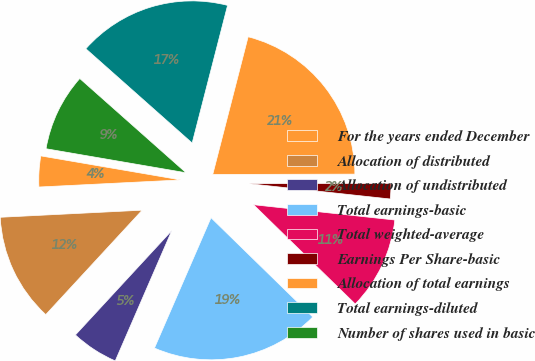Convert chart. <chart><loc_0><loc_0><loc_500><loc_500><pie_chart><fcel>For the years ended December<fcel>Allocation of distributed<fcel>Allocation of undistributed<fcel>Total earnings-basic<fcel>Total weighted-average<fcel>Earnings Per Share-basic<fcel>Allocation of total earnings<fcel>Total earnings-diluted<fcel>Number of shares used in basic<nl><fcel>3.5%<fcel>12.34%<fcel>5.35%<fcel>19.21%<fcel>10.59%<fcel>1.75%<fcel>20.96%<fcel>17.46%<fcel>8.84%<nl></chart> 